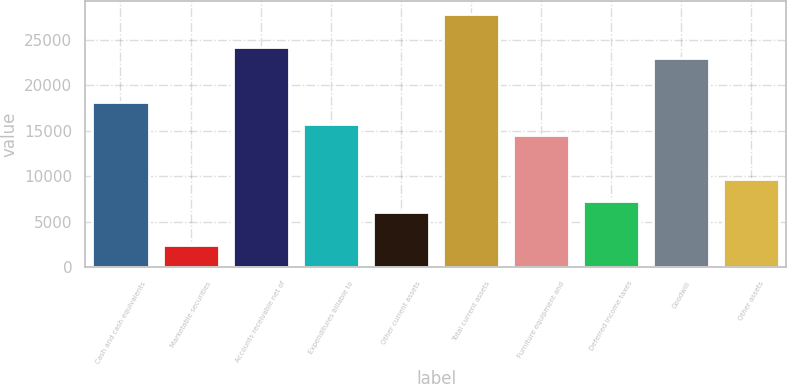Convert chart. <chart><loc_0><loc_0><loc_500><loc_500><bar_chart><fcel>Cash and cash equivalents<fcel>Marketable securities<fcel>Accounts receivable net of<fcel>Expenditures billable to<fcel>Other current assets<fcel>Total current assets<fcel>Furniture equipment and<fcel>Deferred income taxes<fcel>Goodwill<fcel>Other assets<nl><fcel>18180.8<fcel>2436.24<fcel>24236.4<fcel>15758.6<fcel>6069.6<fcel>27869.8<fcel>14547.4<fcel>7280.72<fcel>23025.3<fcel>9702.96<nl></chart> 